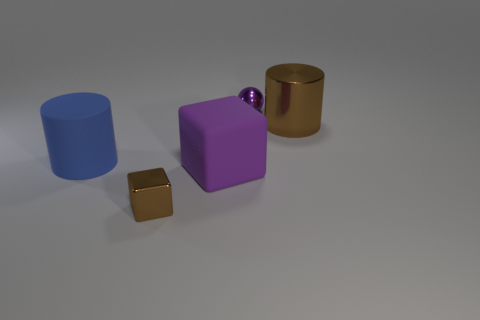Are there an equal number of blocks in front of the tiny metal block and brown cylinders in front of the small shiny sphere?
Your answer should be compact. No. The thing that is right of the small metallic thing behind the big rubber cylinder is what shape?
Offer a terse response. Cylinder. There is a large brown object that is the same shape as the big blue object; what is its material?
Offer a terse response. Metal. What color is the object that is the same size as the metal block?
Make the answer very short. Purple. Are there the same number of metal objects behind the big purple object and purple cylinders?
Your answer should be compact. No. What is the color of the big object that is left of the small thing to the left of the purple metal object?
Keep it short and to the point. Blue. There is a metallic object in front of the brown shiny thing right of the small block; what is its size?
Offer a terse response. Small. What is the size of the metallic block that is the same color as the large metal object?
Your answer should be very brief. Small. What number of other objects are there of the same size as the purple cube?
Your answer should be very brief. 2. What is the color of the block that is behind the small metallic thing to the left of the ball on the right side of the small brown shiny thing?
Offer a very short reply. Purple. 